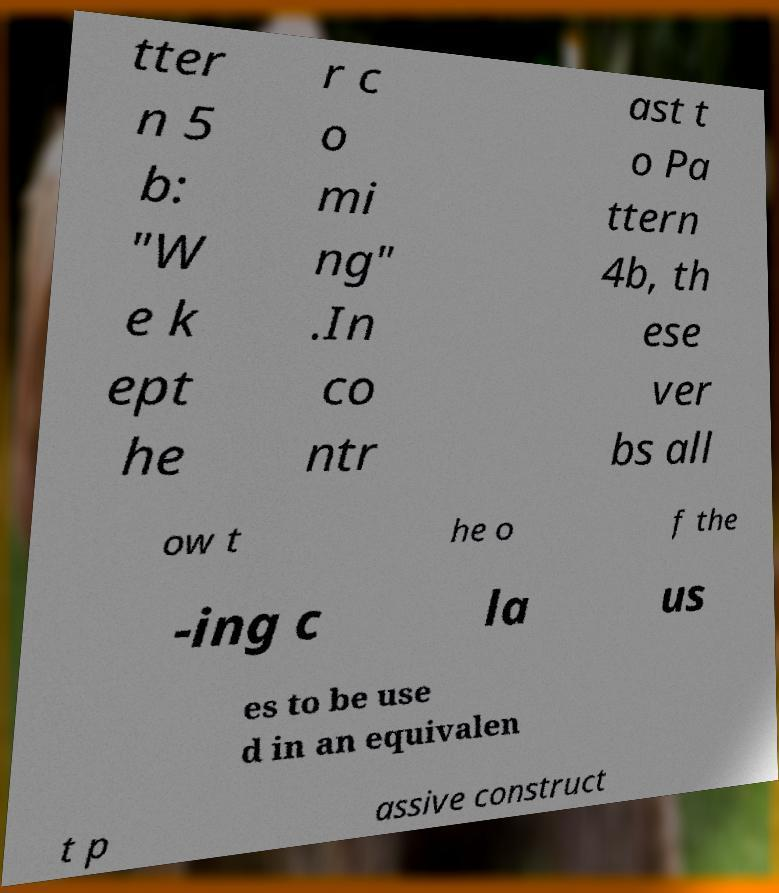I need the written content from this picture converted into text. Can you do that? tter n 5 b: "W e k ept he r c o mi ng" .In co ntr ast t o Pa ttern 4b, th ese ver bs all ow t he o f the -ing c la us es to be use d in an equivalen t p assive construct 